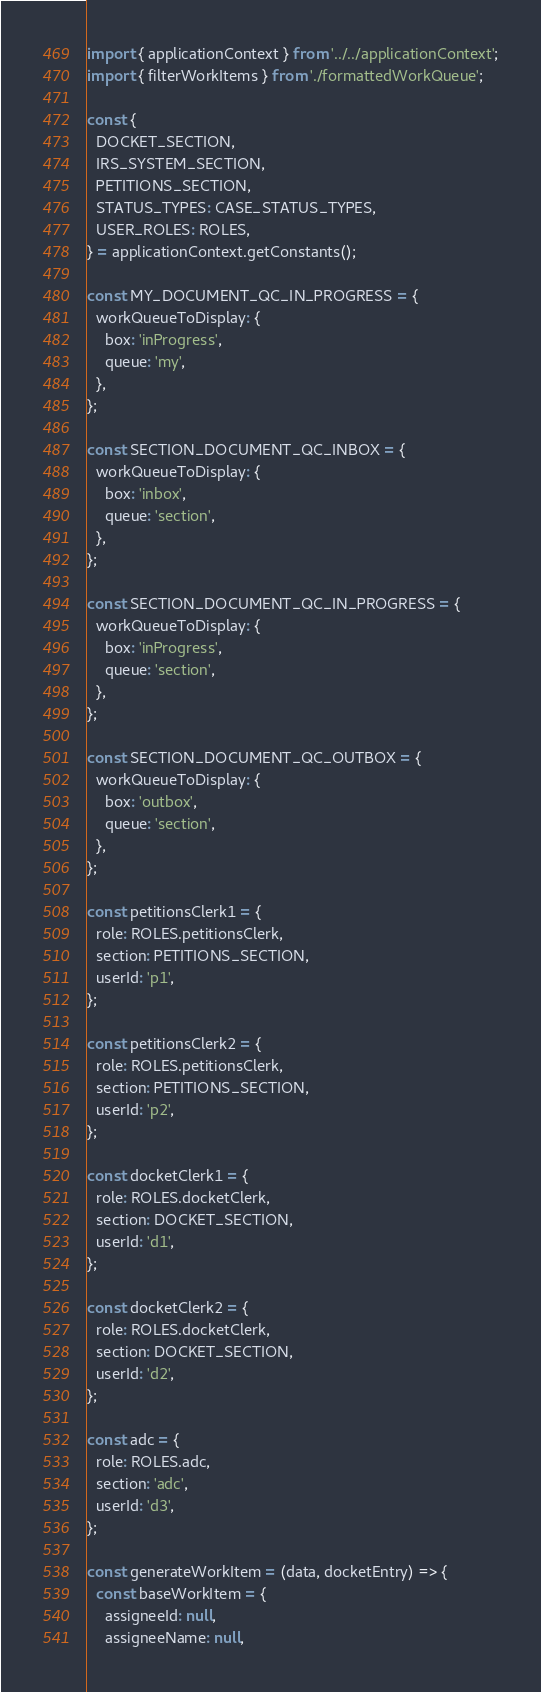Convert code to text. <code><loc_0><loc_0><loc_500><loc_500><_JavaScript_>import { applicationContext } from '../../applicationContext';
import { filterWorkItems } from './formattedWorkQueue';

const {
  DOCKET_SECTION,
  IRS_SYSTEM_SECTION,
  PETITIONS_SECTION,
  STATUS_TYPES: CASE_STATUS_TYPES,
  USER_ROLES: ROLES,
} = applicationContext.getConstants();

const MY_DOCUMENT_QC_IN_PROGRESS = {
  workQueueToDisplay: {
    box: 'inProgress',
    queue: 'my',
  },
};

const SECTION_DOCUMENT_QC_INBOX = {
  workQueueToDisplay: {
    box: 'inbox',
    queue: 'section',
  },
};

const SECTION_DOCUMENT_QC_IN_PROGRESS = {
  workQueueToDisplay: {
    box: 'inProgress',
    queue: 'section',
  },
};

const SECTION_DOCUMENT_QC_OUTBOX = {
  workQueueToDisplay: {
    box: 'outbox',
    queue: 'section',
  },
};

const petitionsClerk1 = {
  role: ROLES.petitionsClerk,
  section: PETITIONS_SECTION,
  userId: 'p1',
};

const petitionsClerk2 = {
  role: ROLES.petitionsClerk,
  section: PETITIONS_SECTION,
  userId: 'p2',
};

const docketClerk1 = {
  role: ROLES.docketClerk,
  section: DOCKET_SECTION,
  userId: 'd1',
};

const docketClerk2 = {
  role: ROLES.docketClerk,
  section: DOCKET_SECTION,
  userId: 'd2',
};

const adc = {
  role: ROLES.adc,
  section: 'adc',
  userId: 'd3',
};

const generateWorkItem = (data, docketEntry) => {
  const baseWorkItem = {
    assigneeId: null,
    assigneeName: null,</code> 